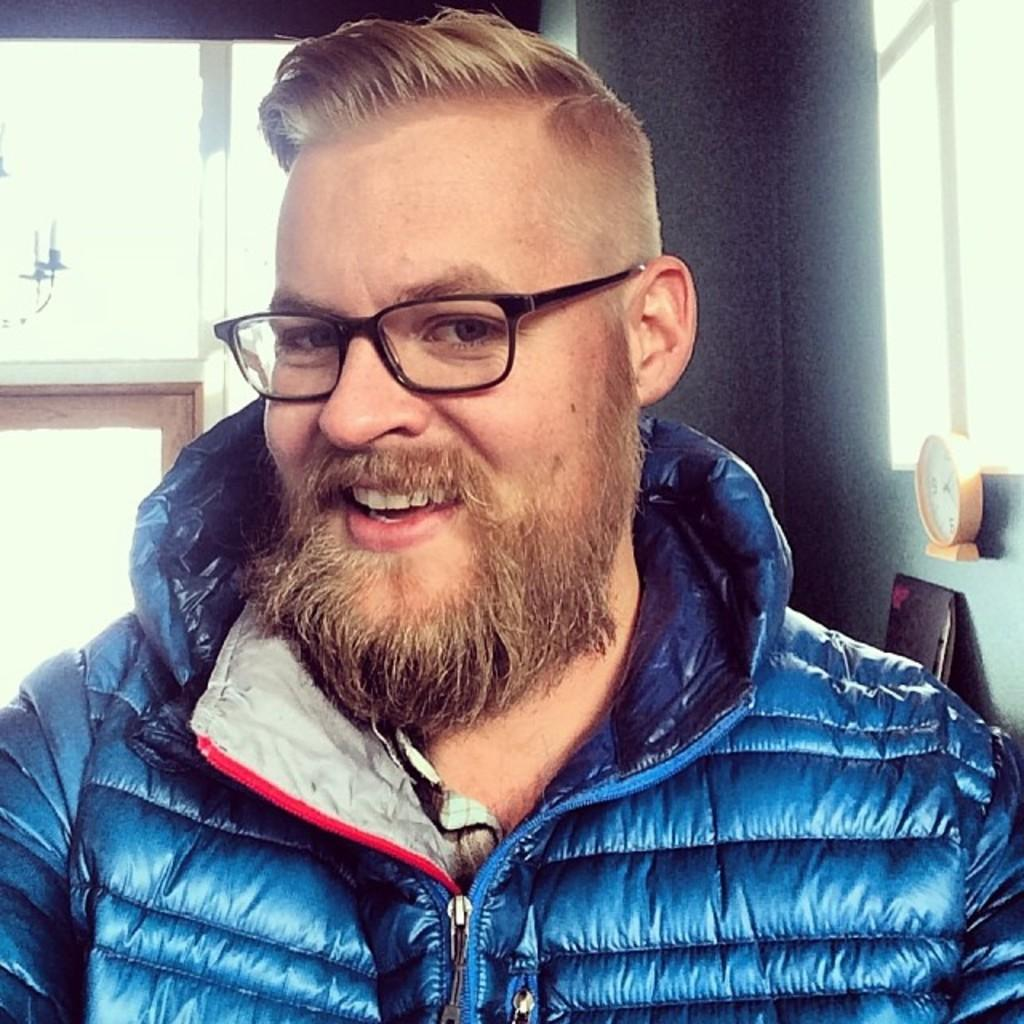What is the main subject in the foreground of the image? There is a person in the foreground of the image. What can be observed about the person's appearance? The person is wearing spectacles. What is the person's facial expression? The person is smiling. What type of architectural feature can be seen in the background? There are glass windows in the background. What time-related object is present in the background? There is a clock in the background. What other features can be seen in the background? There is a wall and other objects in the background. How many friends are visible in the image? There are no friends visible in the image; it only features a person in the foreground. What type of wire is being used to support the clock in the image? There is no wire visible in the image; the clock is mounted on the wall in the background. 